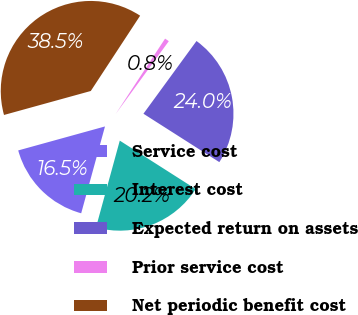Convert chart to OTSL. <chart><loc_0><loc_0><loc_500><loc_500><pie_chart><fcel>Service cost<fcel>Interest cost<fcel>Expected return on assets<fcel>Prior service cost<fcel>Net periodic benefit cost<nl><fcel>16.45%<fcel>20.22%<fcel>24.0%<fcel>0.8%<fcel>38.52%<nl></chart> 